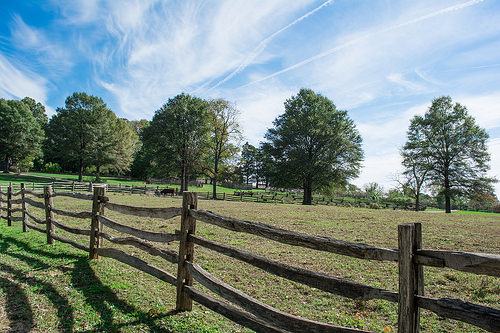<image>
Is the fence next to the tree? No. The fence is not positioned next to the tree. They are located in different areas of the scene. 